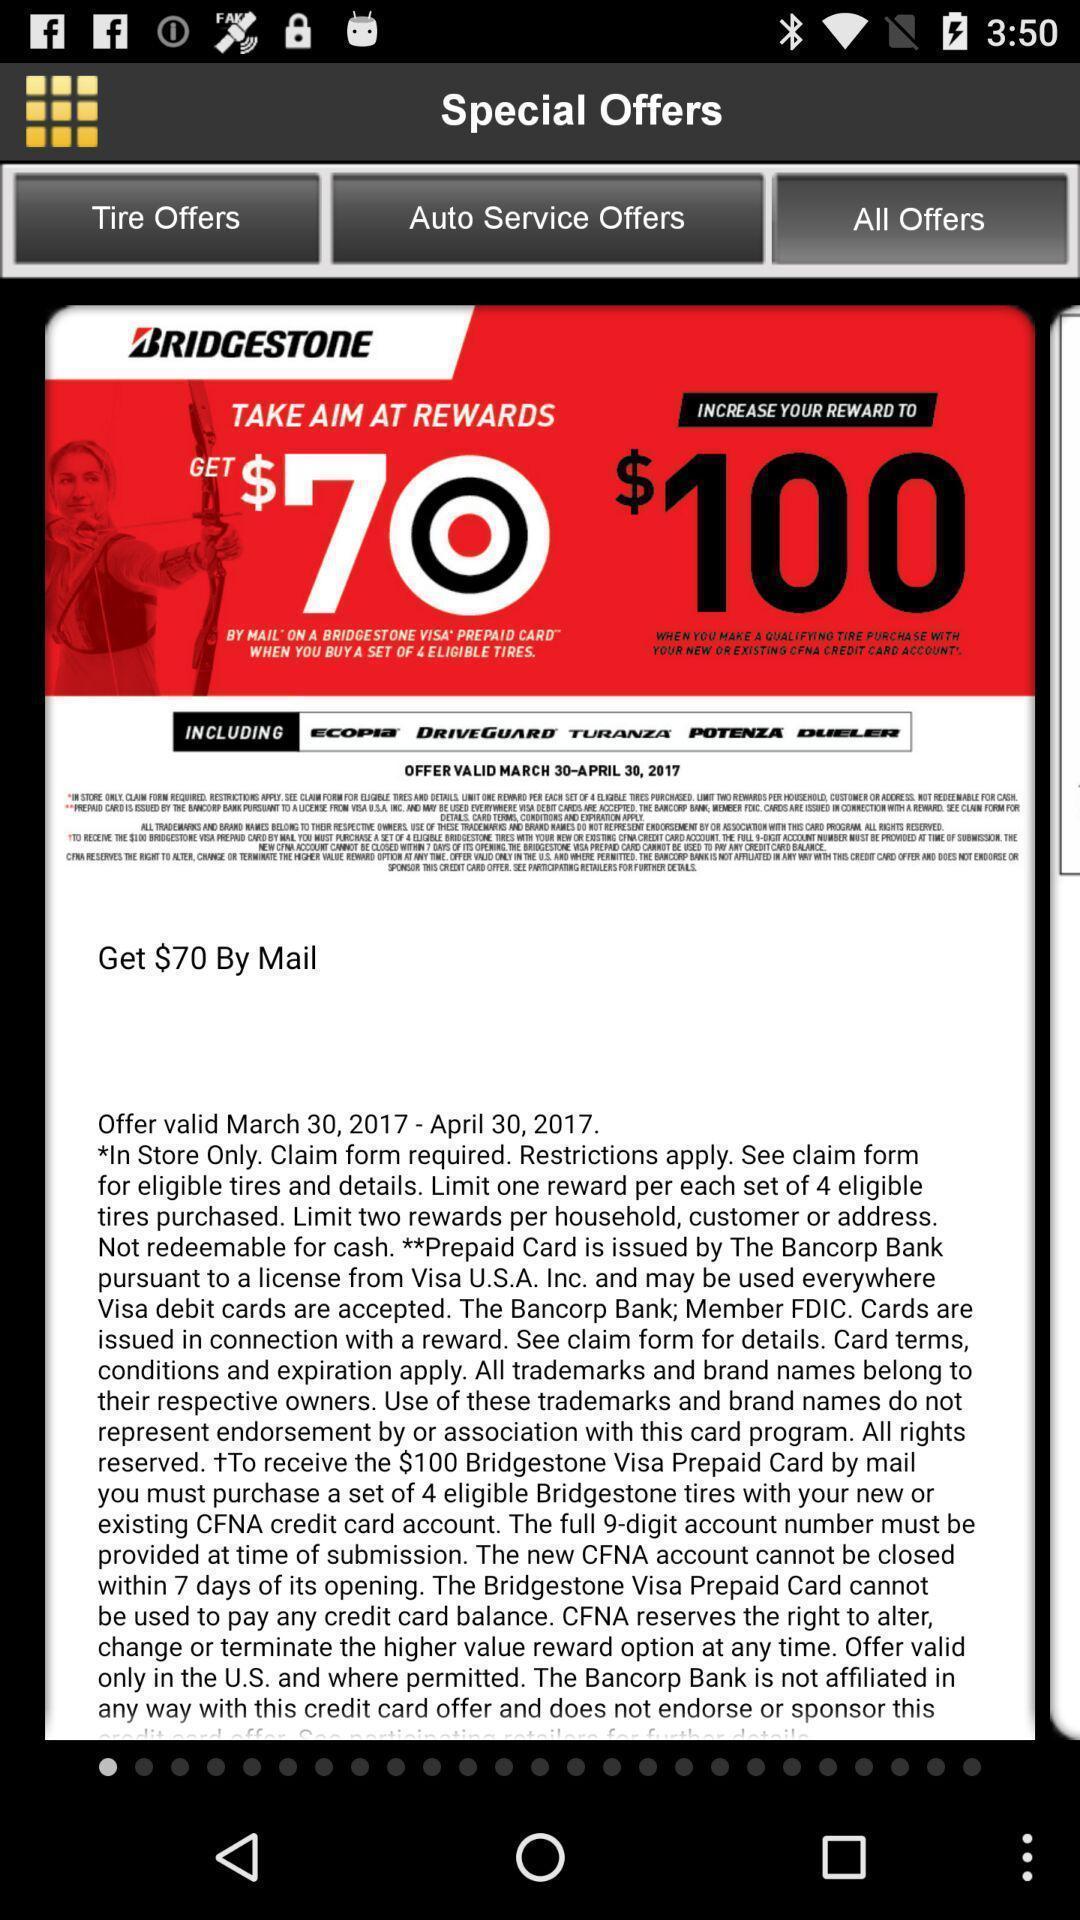Tell me about the visual elements in this screen capture. Page displaying with offer details in the company. 